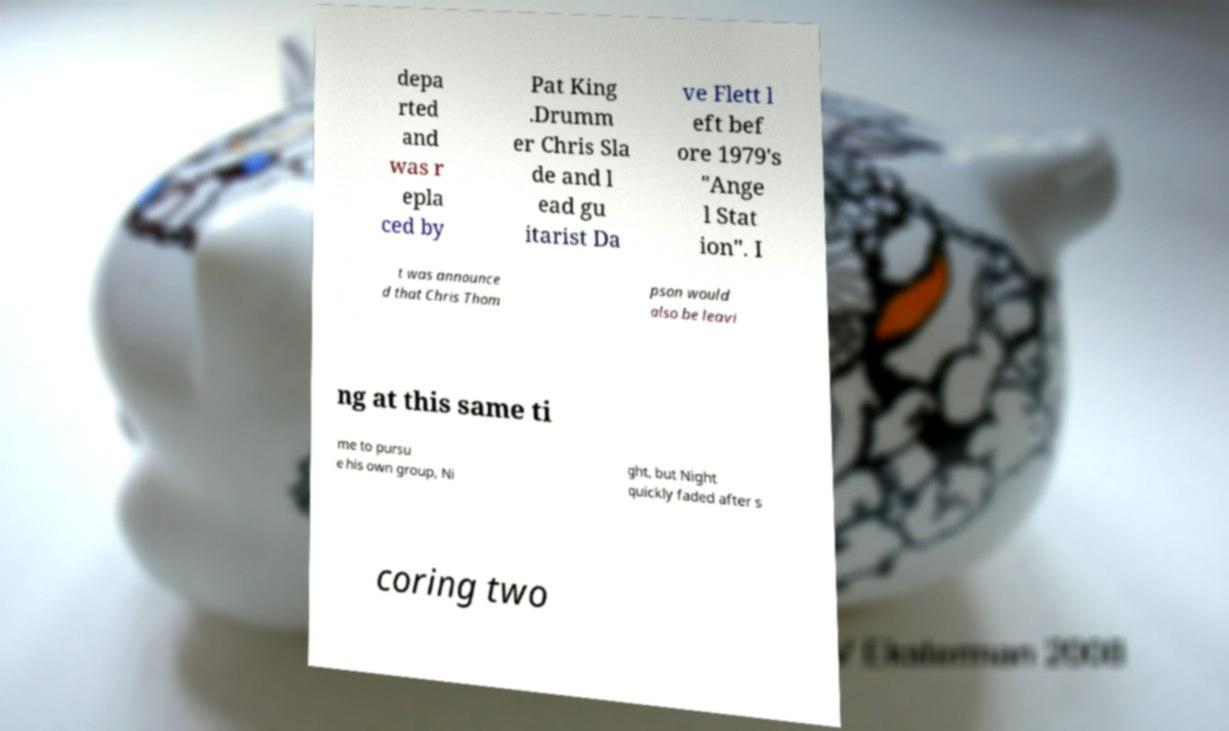I need the written content from this picture converted into text. Can you do that? depa rted and was r epla ced by Pat King .Drumm er Chris Sla de and l ead gu itarist Da ve Flett l eft bef ore 1979's "Ange l Stat ion". I t was announce d that Chris Thom pson would also be leavi ng at this same ti me to pursu e his own group, Ni ght, but Night quickly faded after s coring two 